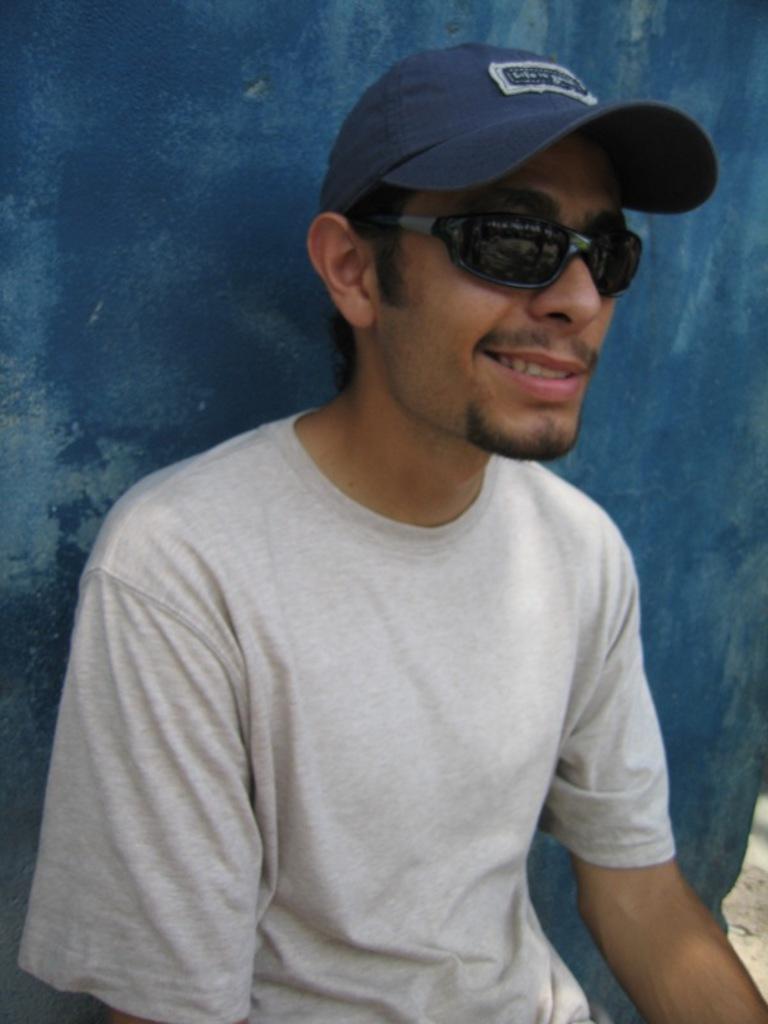Describe this image in one or two sentences. In this picture there is a man who is wearing cap, t-shirts and goggles. He is sitting near to the blue color wall and he is smiling. 